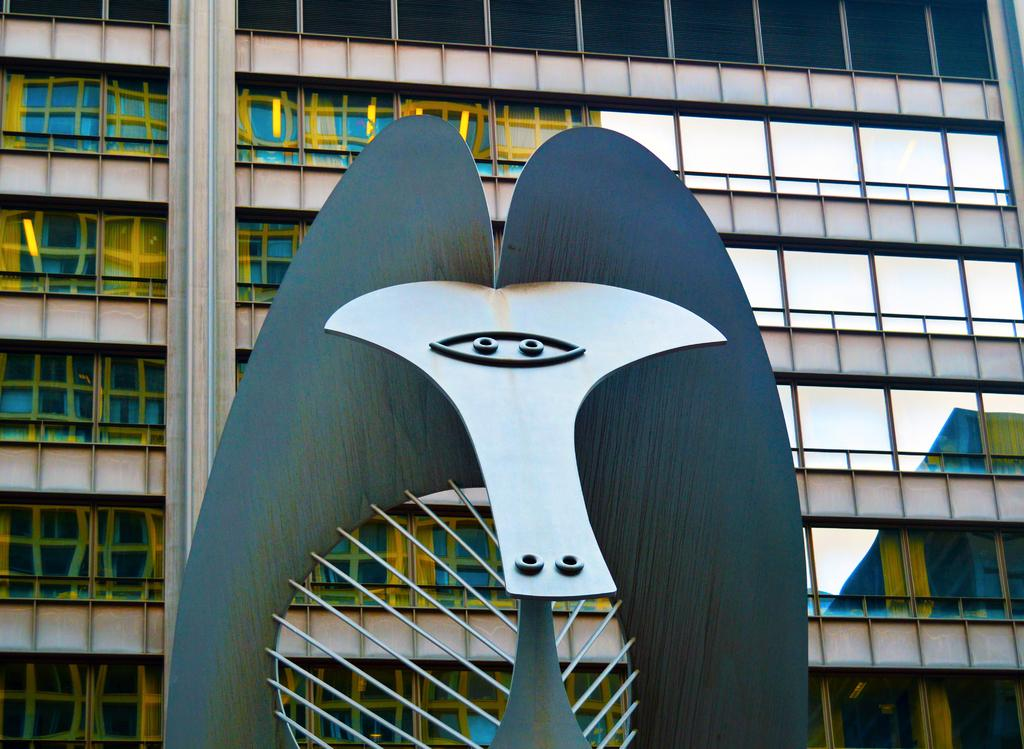What is the main subject in the front of the image? There is an architectural structure in the front of the image. What can be seen behind the architectural structure? There is a building behind the architectural structure. What is unique about the building's appearance? The building is fully covered with glass. Can you see any wounds on the head of the architectural structure in the image? There is no head or any indication of a wound in the image, as the main subjects are architectural structures and buildings. 